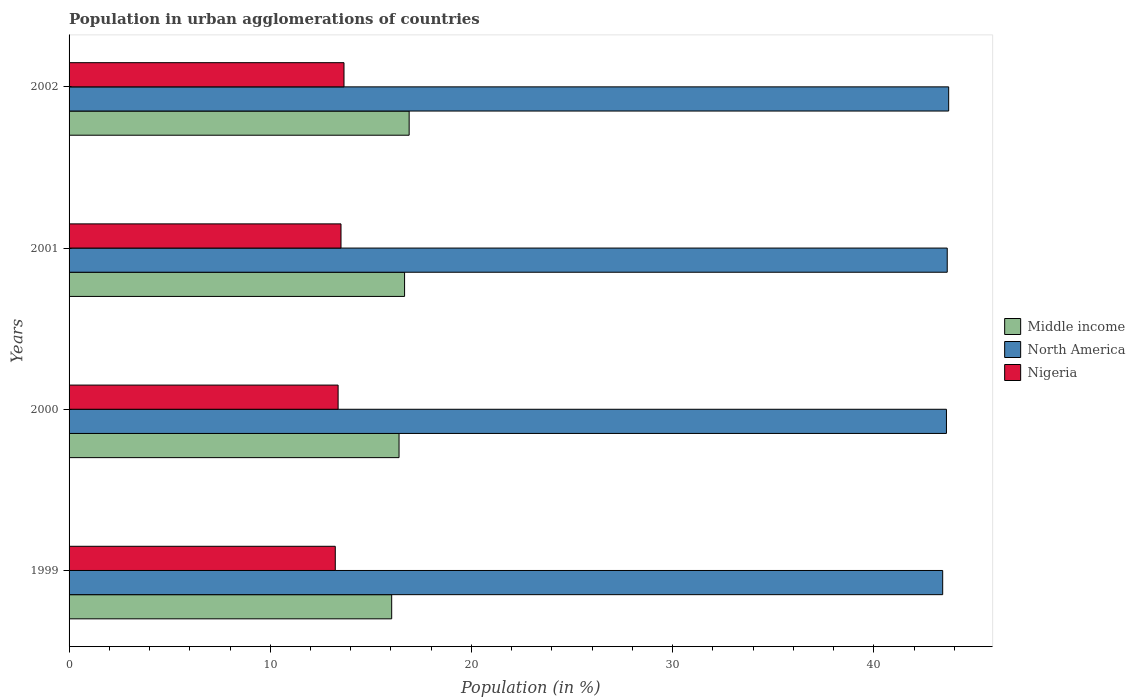How many different coloured bars are there?
Provide a short and direct response. 3. Are the number of bars per tick equal to the number of legend labels?
Keep it short and to the point. Yes. Are the number of bars on each tick of the Y-axis equal?
Your response must be concise. Yes. What is the label of the 3rd group of bars from the top?
Offer a very short reply. 2000. What is the percentage of population in urban agglomerations in North America in 2001?
Ensure brevity in your answer.  43.65. Across all years, what is the maximum percentage of population in urban agglomerations in Nigeria?
Make the answer very short. 13.66. Across all years, what is the minimum percentage of population in urban agglomerations in Middle income?
Your answer should be very brief. 16.03. In which year was the percentage of population in urban agglomerations in Middle income minimum?
Offer a very short reply. 1999. What is the total percentage of population in urban agglomerations in Middle income in the graph?
Your answer should be compact. 66.01. What is the difference between the percentage of population in urban agglomerations in Middle income in 2001 and that in 2002?
Provide a succinct answer. -0.23. What is the difference between the percentage of population in urban agglomerations in North America in 2000 and the percentage of population in urban agglomerations in Nigeria in 2002?
Make the answer very short. 29.94. What is the average percentage of population in urban agglomerations in North America per year?
Make the answer very short. 43.6. In the year 2001, what is the difference between the percentage of population in urban agglomerations in Nigeria and percentage of population in urban agglomerations in North America?
Give a very brief answer. -30.13. In how many years, is the percentage of population in urban agglomerations in North America greater than 22 %?
Give a very brief answer. 4. What is the ratio of the percentage of population in urban agglomerations in Nigeria in 2001 to that in 2002?
Offer a very short reply. 0.99. Is the percentage of population in urban agglomerations in North America in 1999 less than that in 2001?
Ensure brevity in your answer.  Yes. What is the difference between the highest and the second highest percentage of population in urban agglomerations in Nigeria?
Your answer should be compact. 0.15. What is the difference between the highest and the lowest percentage of population in urban agglomerations in North America?
Make the answer very short. 0.3. In how many years, is the percentage of population in urban agglomerations in North America greater than the average percentage of population in urban agglomerations in North America taken over all years?
Give a very brief answer. 3. What does the 3rd bar from the top in 2000 represents?
Give a very brief answer. Middle income. What does the 1st bar from the bottom in 2000 represents?
Ensure brevity in your answer.  Middle income. Is it the case that in every year, the sum of the percentage of population in urban agglomerations in Nigeria and percentage of population in urban agglomerations in Middle income is greater than the percentage of population in urban agglomerations in North America?
Provide a short and direct response. No. How many years are there in the graph?
Your answer should be compact. 4. Are the values on the major ticks of X-axis written in scientific E-notation?
Provide a short and direct response. No. Does the graph contain grids?
Give a very brief answer. No. Where does the legend appear in the graph?
Offer a very short reply. Center right. How are the legend labels stacked?
Offer a very short reply. Vertical. What is the title of the graph?
Make the answer very short. Population in urban agglomerations of countries. What is the label or title of the Y-axis?
Ensure brevity in your answer.  Years. What is the Population (in %) in Middle income in 1999?
Ensure brevity in your answer.  16.03. What is the Population (in %) in North America in 1999?
Offer a terse response. 43.42. What is the Population (in %) of Nigeria in 1999?
Your answer should be compact. 13.23. What is the Population (in %) of Middle income in 2000?
Your answer should be very brief. 16.4. What is the Population (in %) in North America in 2000?
Your answer should be very brief. 43.61. What is the Population (in %) in Nigeria in 2000?
Make the answer very short. 13.37. What is the Population (in %) in Middle income in 2001?
Provide a short and direct response. 16.68. What is the Population (in %) in North America in 2001?
Offer a very short reply. 43.65. What is the Population (in %) of Nigeria in 2001?
Give a very brief answer. 13.52. What is the Population (in %) in Middle income in 2002?
Your response must be concise. 16.9. What is the Population (in %) in North America in 2002?
Provide a succinct answer. 43.72. What is the Population (in %) of Nigeria in 2002?
Give a very brief answer. 13.66. Across all years, what is the maximum Population (in %) in Middle income?
Give a very brief answer. 16.9. Across all years, what is the maximum Population (in %) in North America?
Your response must be concise. 43.72. Across all years, what is the maximum Population (in %) in Nigeria?
Offer a terse response. 13.66. Across all years, what is the minimum Population (in %) of Middle income?
Your answer should be compact. 16.03. Across all years, what is the minimum Population (in %) of North America?
Give a very brief answer. 43.42. Across all years, what is the minimum Population (in %) in Nigeria?
Ensure brevity in your answer.  13.23. What is the total Population (in %) in Middle income in the graph?
Your answer should be very brief. 66.01. What is the total Population (in %) in North America in the graph?
Provide a succinct answer. 174.4. What is the total Population (in %) of Nigeria in the graph?
Provide a short and direct response. 53.78. What is the difference between the Population (in %) of Middle income in 1999 and that in 2000?
Offer a terse response. -0.37. What is the difference between the Population (in %) of North America in 1999 and that in 2000?
Provide a succinct answer. -0.19. What is the difference between the Population (in %) in Nigeria in 1999 and that in 2000?
Your answer should be very brief. -0.14. What is the difference between the Population (in %) of Middle income in 1999 and that in 2001?
Provide a short and direct response. -0.64. What is the difference between the Population (in %) in North America in 1999 and that in 2001?
Your answer should be compact. -0.23. What is the difference between the Population (in %) in Nigeria in 1999 and that in 2001?
Your answer should be compact. -0.28. What is the difference between the Population (in %) of Middle income in 1999 and that in 2002?
Ensure brevity in your answer.  -0.87. What is the difference between the Population (in %) of North America in 1999 and that in 2002?
Offer a very short reply. -0.3. What is the difference between the Population (in %) in Nigeria in 1999 and that in 2002?
Provide a short and direct response. -0.43. What is the difference between the Population (in %) in Middle income in 2000 and that in 2001?
Provide a succinct answer. -0.28. What is the difference between the Population (in %) in North America in 2000 and that in 2001?
Make the answer very short. -0.04. What is the difference between the Population (in %) in Nigeria in 2000 and that in 2001?
Keep it short and to the point. -0.14. What is the difference between the Population (in %) of Middle income in 2000 and that in 2002?
Your answer should be very brief. -0.5. What is the difference between the Population (in %) of North America in 2000 and that in 2002?
Ensure brevity in your answer.  -0.11. What is the difference between the Population (in %) of Nigeria in 2000 and that in 2002?
Provide a succinct answer. -0.29. What is the difference between the Population (in %) in Middle income in 2001 and that in 2002?
Provide a succinct answer. -0.23. What is the difference between the Population (in %) in North America in 2001 and that in 2002?
Offer a terse response. -0.07. What is the difference between the Population (in %) of Nigeria in 2001 and that in 2002?
Your answer should be compact. -0.15. What is the difference between the Population (in %) of Middle income in 1999 and the Population (in %) of North America in 2000?
Make the answer very short. -27.57. What is the difference between the Population (in %) in Middle income in 1999 and the Population (in %) in Nigeria in 2000?
Your answer should be compact. 2.66. What is the difference between the Population (in %) of North America in 1999 and the Population (in %) of Nigeria in 2000?
Give a very brief answer. 30.05. What is the difference between the Population (in %) in Middle income in 1999 and the Population (in %) in North America in 2001?
Your answer should be compact. -27.61. What is the difference between the Population (in %) of Middle income in 1999 and the Population (in %) of Nigeria in 2001?
Ensure brevity in your answer.  2.52. What is the difference between the Population (in %) in North America in 1999 and the Population (in %) in Nigeria in 2001?
Give a very brief answer. 29.91. What is the difference between the Population (in %) of Middle income in 1999 and the Population (in %) of North America in 2002?
Offer a very short reply. -27.68. What is the difference between the Population (in %) of Middle income in 1999 and the Population (in %) of Nigeria in 2002?
Your answer should be very brief. 2.37. What is the difference between the Population (in %) of North America in 1999 and the Population (in %) of Nigeria in 2002?
Offer a terse response. 29.76. What is the difference between the Population (in %) in Middle income in 2000 and the Population (in %) in North America in 2001?
Offer a terse response. -27.25. What is the difference between the Population (in %) in Middle income in 2000 and the Population (in %) in Nigeria in 2001?
Keep it short and to the point. 2.88. What is the difference between the Population (in %) in North America in 2000 and the Population (in %) in Nigeria in 2001?
Your answer should be very brief. 30.09. What is the difference between the Population (in %) in Middle income in 2000 and the Population (in %) in North America in 2002?
Provide a short and direct response. -27.32. What is the difference between the Population (in %) of Middle income in 2000 and the Population (in %) of Nigeria in 2002?
Your response must be concise. 2.74. What is the difference between the Population (in %) in North America in 2000 and the Population (in %) in Nigeria in 2002?
Make the answer very short. 29.94. What is the difference between the Population (in %) in Middle income in 2001 and the Population (in %) in North America in 2002?
Provide a short and direct response. -27.04. What is the difference between the Population (in %) in Middle income in 2001 and the Population (in %) in Nigeria in 2002?
Offer a terse response. 3.01. What is the difference between the Population (in %) of North America in 2001 and the Population (in %) of Nigeria in 2002?
Ensure brevity in your answer.  29.98. What is the average Population (in %) in Middle income per year?
Offer a terse response. 16.5. What is the average Population (in %) in North America per year?
Provide a short and direct response. 43.6. What is the average Population (in %) of Nigeria per year?
Offer a very short reply. 13.45. In the year 1999, what is the difference between the Population (in %) of Middle income and Population (in %) of North America?
Your answer should be very brief. -27.39. In the year 1999, what is the difference between the Population (in %) of Middle income and Population (in %) of Nigeria?
Keep it short and to the point. 2.8. In the year 1999, what is the difference between the Population (in %) in North America and Population (in %) in Nigeria?
Your answer should be compact. 30.19. In the year 2000, what is the difference between the Population (in %) of Middle income and Population (in %) of North America?
Give a very brief answer. -27.21. In the year 2000, what is the difference between the Population (in %) of Middle income and Population (in %) of Nigeria?
Provide a short and direct response. 3.03. In the year 2000, what is the difference between the Population (in %) in North America and Population (in %) in Nigeria?
Offer a terse response. 30.24. In the year 2001, what is the difference between the Population (in %) of Middle income and Population (in %) of North America?
Your response must be concise. -26.97. In the year 2001, what is the difference between the Population (in %) in Middle income and Population (in %) in Nigeria?
Your answer should be compact. 3.16. In the year 2001, what is the difference between the Population (in %) in North America and Population (in %) in Nigeria?
Make the answer very short. 30.13. In the year 2002, what is the difference between the Population (in %) in Middle income and Population (in %) in North America?
Give a very brief answer. -26.82. In the year 2002, what is the difference between the Population (in %) in Middle income and Population (in %) in Nigeria?
Keep it short and to the point. 3.24. In the year 2002, what is the difference between the Population (in %) of North America and Population (in %) of Nigeria?
Ensure brevity in your answer.  30.05. What is the ratio of the Population (in %) in Middle income in 1999 to that in 2000?
Ensure brevity in your answer.  0.98. What is the ratio of the Population (in %) in North America in 1999 to that in 2000?
Keep it short and to the point. 1. What is the ratio of the Population (in %) of Middle income in 1999 to that in 2001?
Provide a short and direct response. 0.96. What is the ratio of the Population (in %) of North America in 1999 to that in 2001?
Ensure brevity in your answer.  0.99. What is the ratio of the Population (in %) in Nigeria in 1999 to that in 2001?
Your answer should be very brief. 0.98. What is the ratio of the Population (in %) in Middle income in 1999 to that in 2002?
Keep it short and to the point. 0.95. What is the ratio of the Population (in %) in Nigeria in 1999 to that in 2002?
Give a very brief answer. 0.97. What is the ratio of the Population (in %) in Middle income in 2000 to that in 2001?
Make the answer very short. 0.98. What is the ratio of the Population (in %) of North America in 2000 to that in 2001?
Give a very brief answer. 1. What is the ratio of the Population (in %) in Nigeria in 2000 to that in 2001?
Your response must be concise. 0.99. What is the ratio of the Population (in %) in Middle income in 2000 to that in 2002?
Ensure brevity in your answer.  0.97. What is the ratio of the Population (in %) in Nigeria in 2000 to that in 2002?
Your response must be concise. 0.98. What is the ratio of the Population (in %) in Middle income in 2001 to that in 2002?
Your answer should be compact. 0.99. What is the ratio of the Population (in %) of North America in 2001 to that in 2002?
Offer a very short reply. 1. What is the difference between the highest and the second highest Population (in %) in Middle income?
Give a very brief answer. 0.23. What is the difference between the highest and the second highest Population (in %) in North America?
Your answer should be compact. 0.07. What is the difference between the highest and the second highest Population (in %) in Nigeria?
Your response must be concise. 0.15. What is the difference between the highest and the lowest Population (in %) of Middle income?
Give a very brief answer. 0.87. What is the difference between the highest and the lowest Population (in %) of North America?
Make the answer very short. 0.3. What is the difference between the highest and the lowest Population (in %) in Nigeria?
Ensure brevity in your answer.  0.43. 